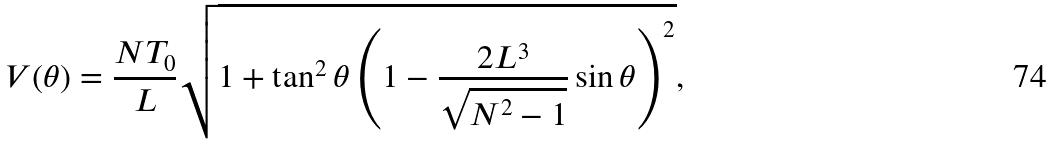Convert formula to latex. <formula><loc_0><loc_0><loc_500><loc_500>V ( \theta ) = \frac { N T _ { 0 } } { L } \sqrt { 1 + \tan ^ { 2 } { \theta } \left ( 1 - \frac { 2 L ^ { 3 } } { \sqrt { N ^ { 2 } - 1 } } \sin { \theta } \right ) ^ { 2 } } ,</formula> 